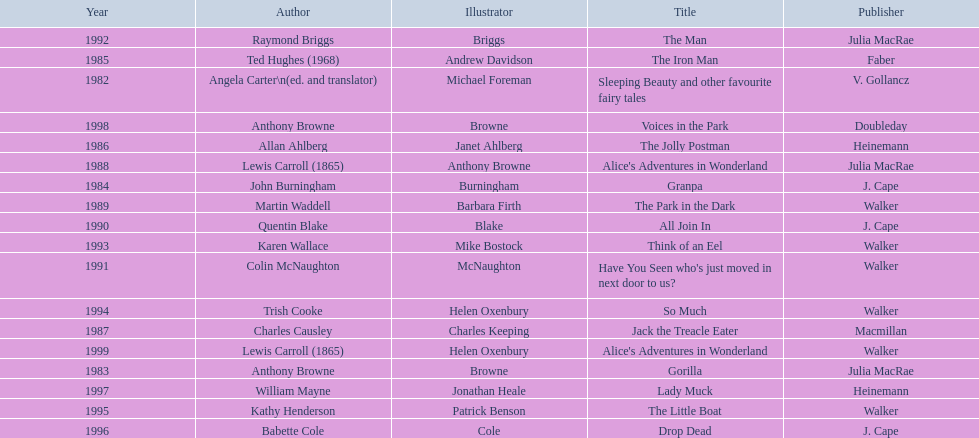How many number of titles are listed for the year 1991? 1. 